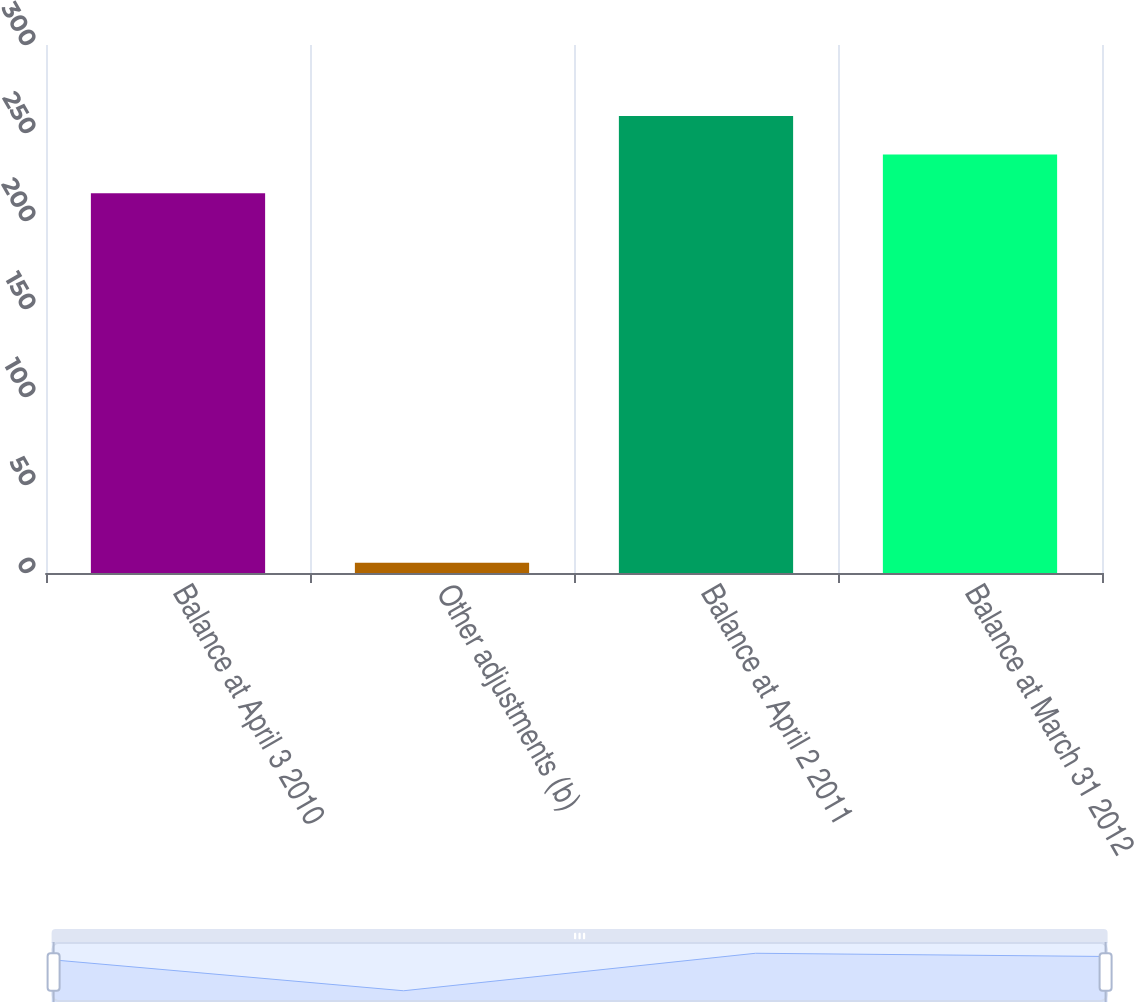Convert chart to OTSL. <chart><loc_0><loc_0><loc_500><loc_500><bar_chart><fcel>Balance at April 3 2010<fcel>Other adjustments (b)<fcel>Balance at April 2 2011<fcel>Balance at March 31 2012<nl><fcel>215.8<fcel>5.8<fcel>259.72<fcel>237.76<nl></chart> 